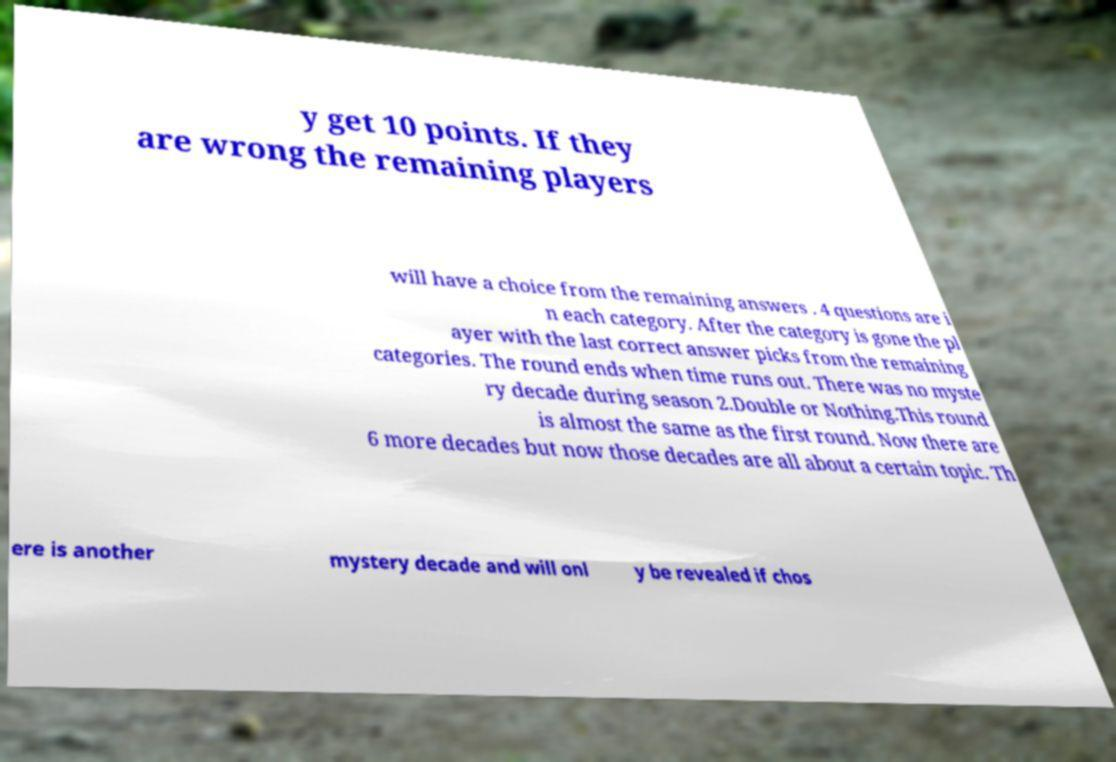Can you accurately transcribe the text from the provided image for me? y get 10 points. If they are wrong the remaining players will have a choice from the remaining answers . 4 questions are i n each category. After the category is gone the pl ayer with the last correct answer picks from the remaining categories. The round ends when time runs out. There was no myste ry decade during season 2.Double or Nothing.This round is almost the same as the first round. Now there are 6 more decades but now those decades are all about a certain topic. Th ere is another mystery decade and will onl y be revealed if chos 